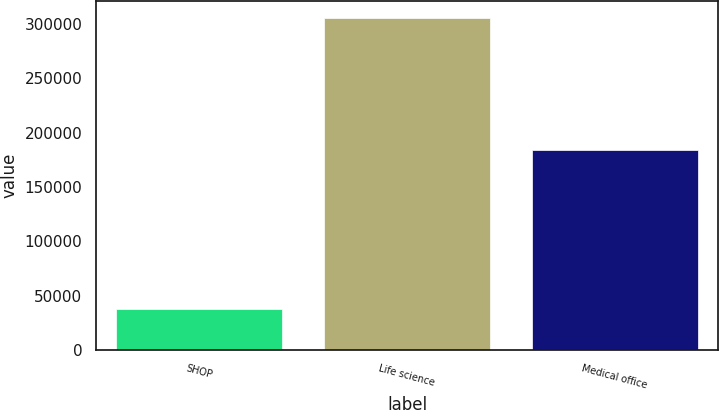Convert chart. <chart><loc_0><loc_0><loc_500><loc_500><bar_chart><fcel>SHOP<fcel>Life science<fcel>Medical office<nl><fcel>37940<fcel>305760<fcel>184115<nl></chart> 